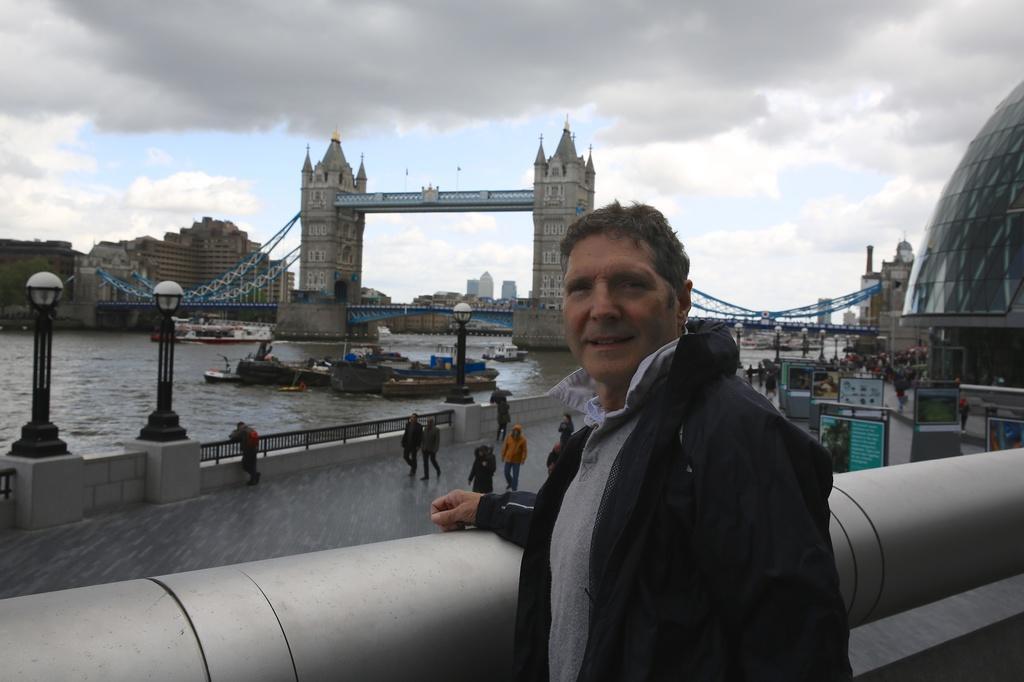Can you describe this image briefly? This picture is clicked outside. In the foreground we can see a man wearing jacket and standing. In the center we can see the group of people, railings, lampposts, bridge and many other items. On the right corner we can see the dome and we can see the boards and some objects in the water body. In the background we can see the sky which is full of clouds and we can see the buildings, spires, bridge and many other objects. 